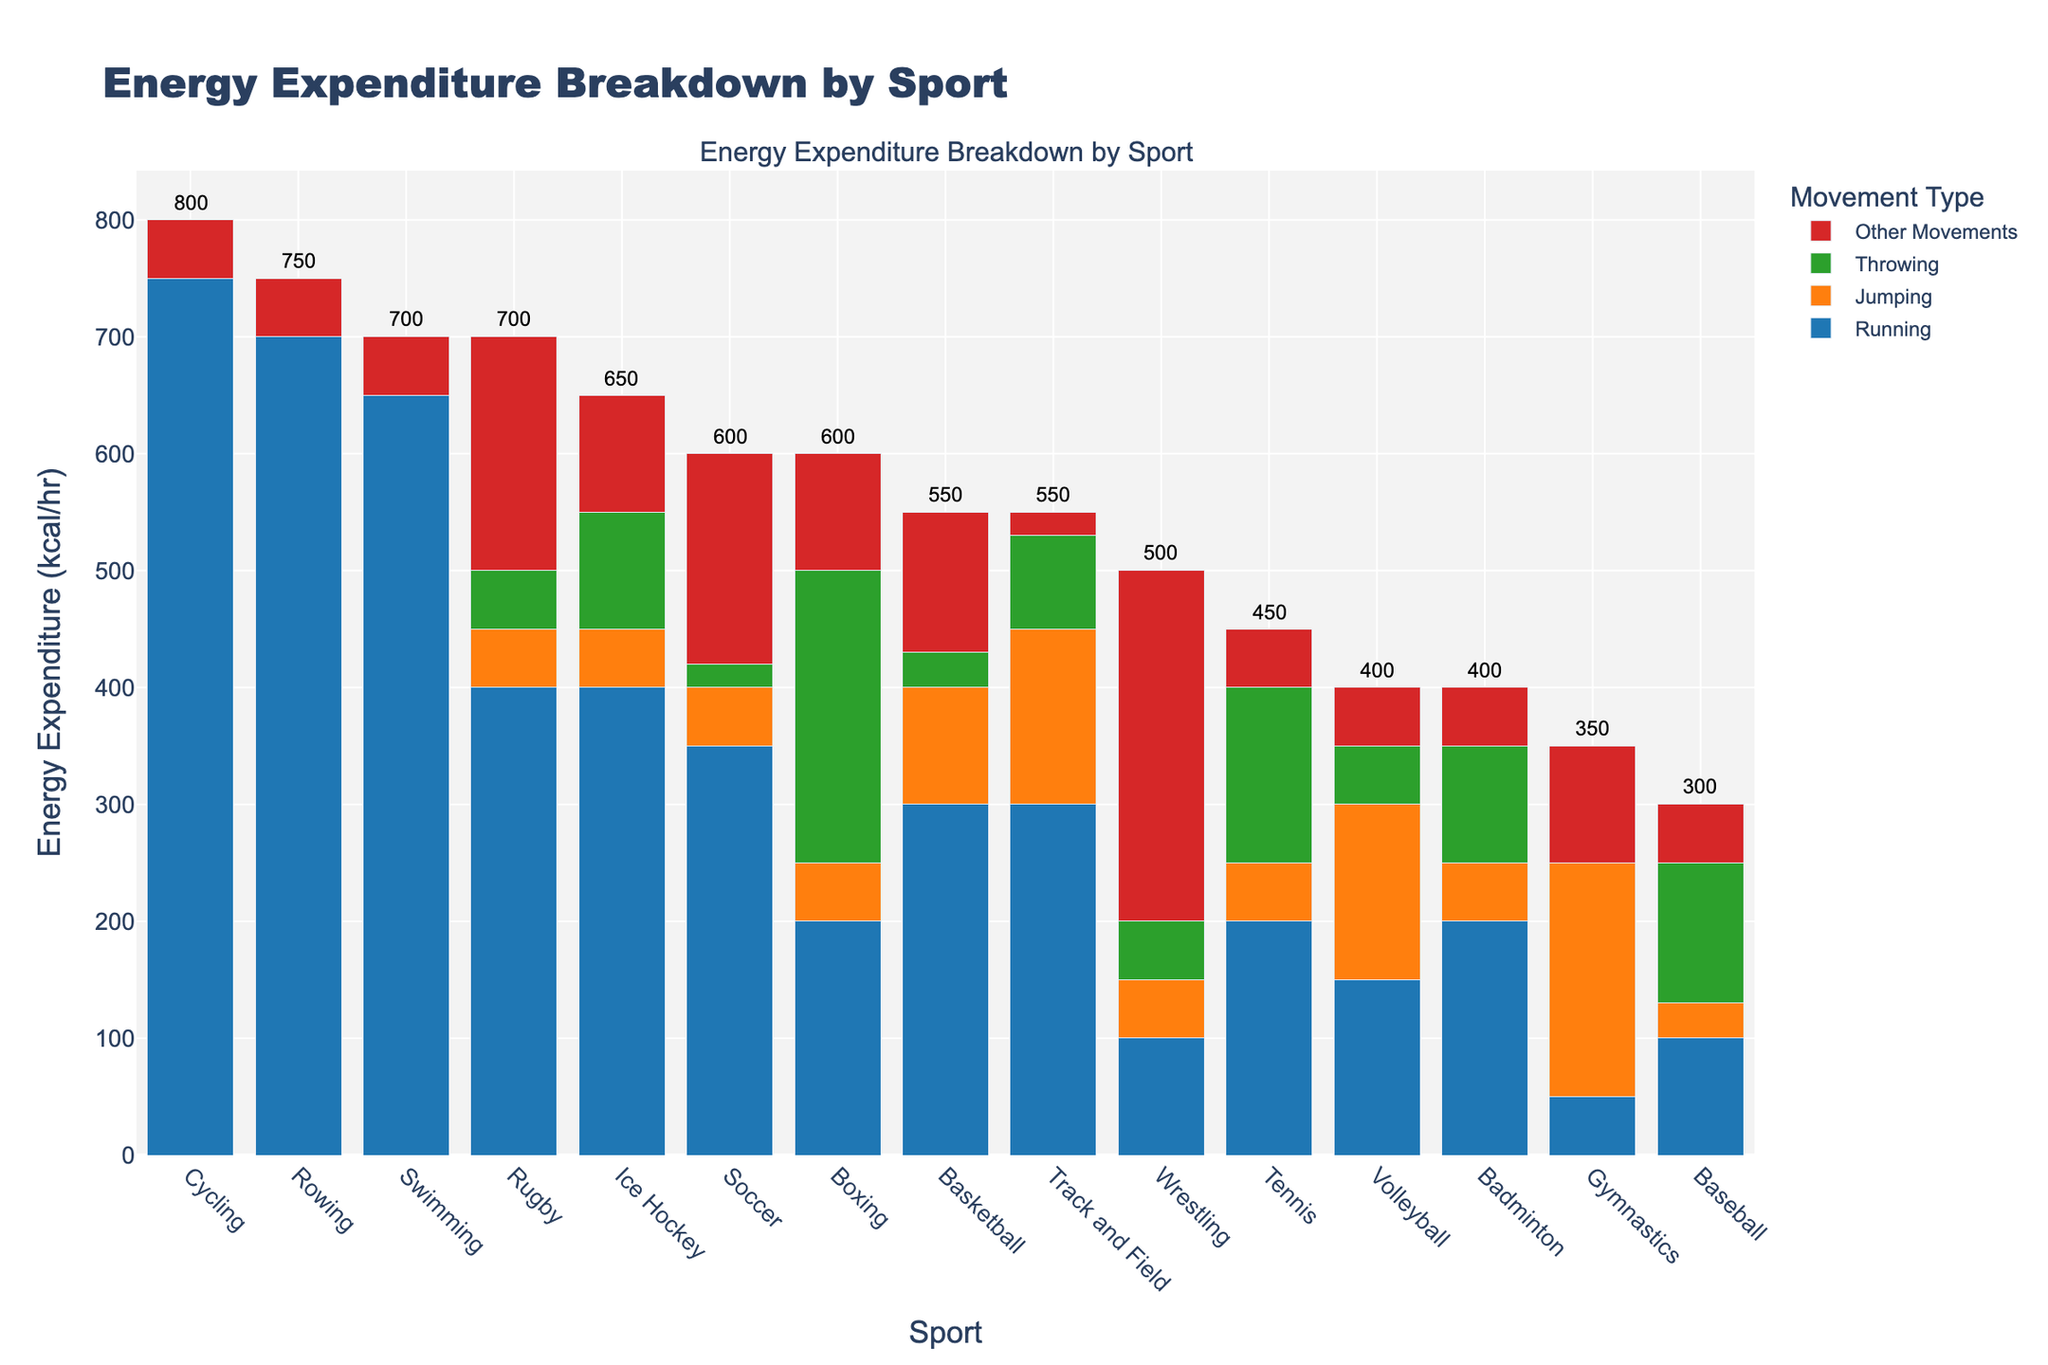Which sport has the highest total energy expenditure? The sport with the highest total energy expenditure has the tallest stacked bar. That sport in the chart is Cycling.
Answer: Cycling What is the total energy expenditure difference between Swimming and Soccer? The bar for Swimming is 700 kcal/hr, and for Soccer, it is 600 kcal/hr. Subtract Soccer's expenditure from Swimming's to find the difference: 700 - 600 = 100.
Answer: 100 kcal/hr Which sport has the least energy expenditure in running? The shortest segment (in blue) at the bottom of the stacked bars representing running should be checked. Gymnastics has the shortest blue segment.
Answer: Gymnastics How much more energy does Rugby spend on running compared to Boxing? Rugby spends 400 kcal/hr on running, while Boxing spends 200 kcal/hr. Calculate the difference: 400 - 200 = 200.
Answer: 200 kcal/hr Summing all expenditure categories, what sport ends up with the median total energy expenditure? The sports sorted by total energy expenditure show the middle sport halfway when the number of sports is arranged from highest to lowest. Here, Gymnastics is the median sport (8th out of 15).
Answer: Gymnastics Which sport has the highest energy expenditure in throwing and how much does it spend? By identifying the tallest green segment in the graph (for Throwing) and then checking the corresponding sport, Boxing has the greatest expenditure in this segment at 250 kcal/hr.
Answer: Boxing spends 250 kcal/hr Which movement type does Swimming spend the least energy on, and how much is it? Since Swimming only has energy expenditures in Running and Other Movements, the smallest value is in Other Movements with 50 kcal/hr.
Answer: Other Movements; 50 kcal/hr Comparing Volleyball and Wrestling, which sport has a higher total energy expenditure, and by how much? Volleyball has 400 kcal/hr and Wrestling has 500 kcal/hr. The difference is calculated as 500 - 400 = 100 kcal/hr, with Wrestling having the higher expenditure.
Answer: Wrestling; 100 kcal/hr What is the combined energy expenditure in jumping for Basketball and Volleyball? Basketball spends 100 kcal/hr and Volleyball spends 150 kcal/hr on jumping. Adding these values gives a total of 100 + 150 = 250 kcal/hr.
Answer: 250 kcal/hr How much energy does Ice Hockey spend on other movements? The red segment (representing other movements) for Ice Hockey can be inspected, which reads 100 kcal/hr.
Answer: 100 kcal/hr 